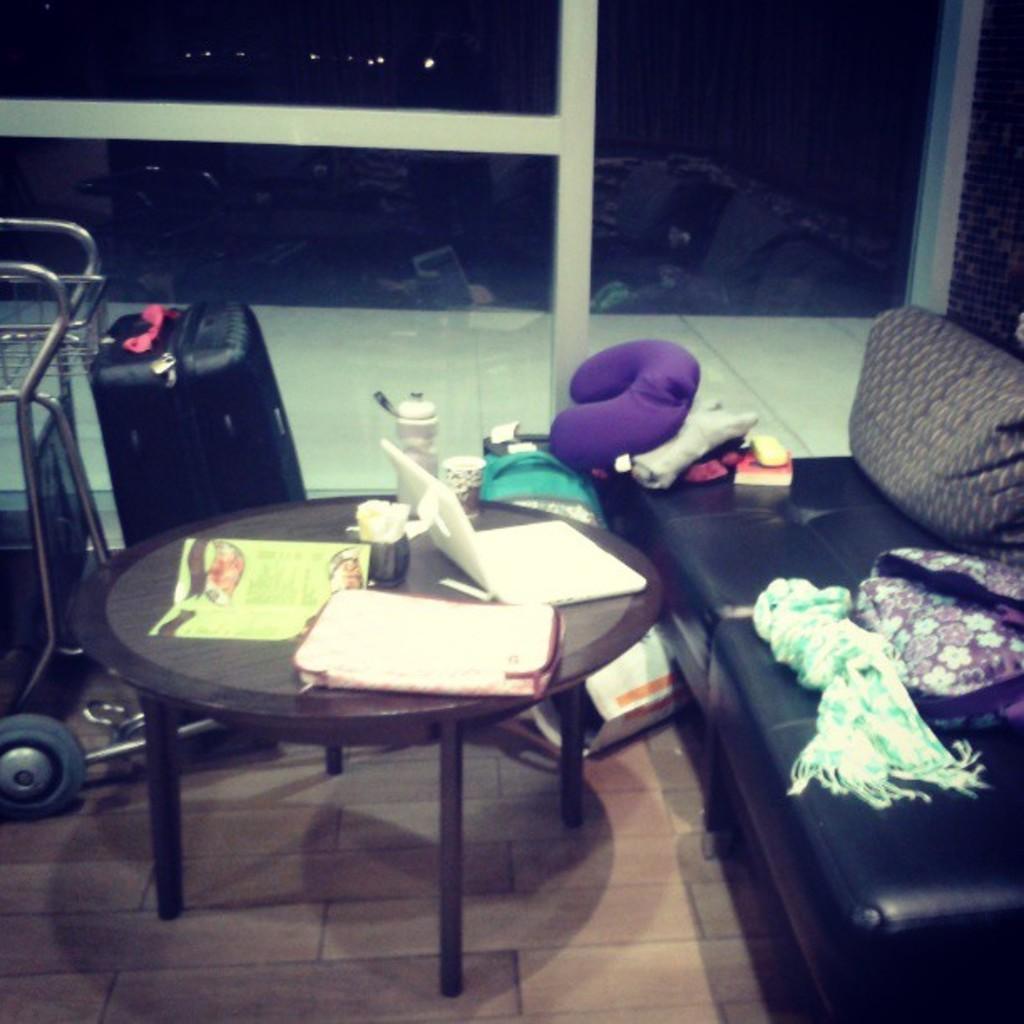Can you describe this image briefly? In this picture there is a laptop, bowl , few things on the table. There is a luggage bag, trolley , sofa, cloth and few other objects. There is a light the background. 